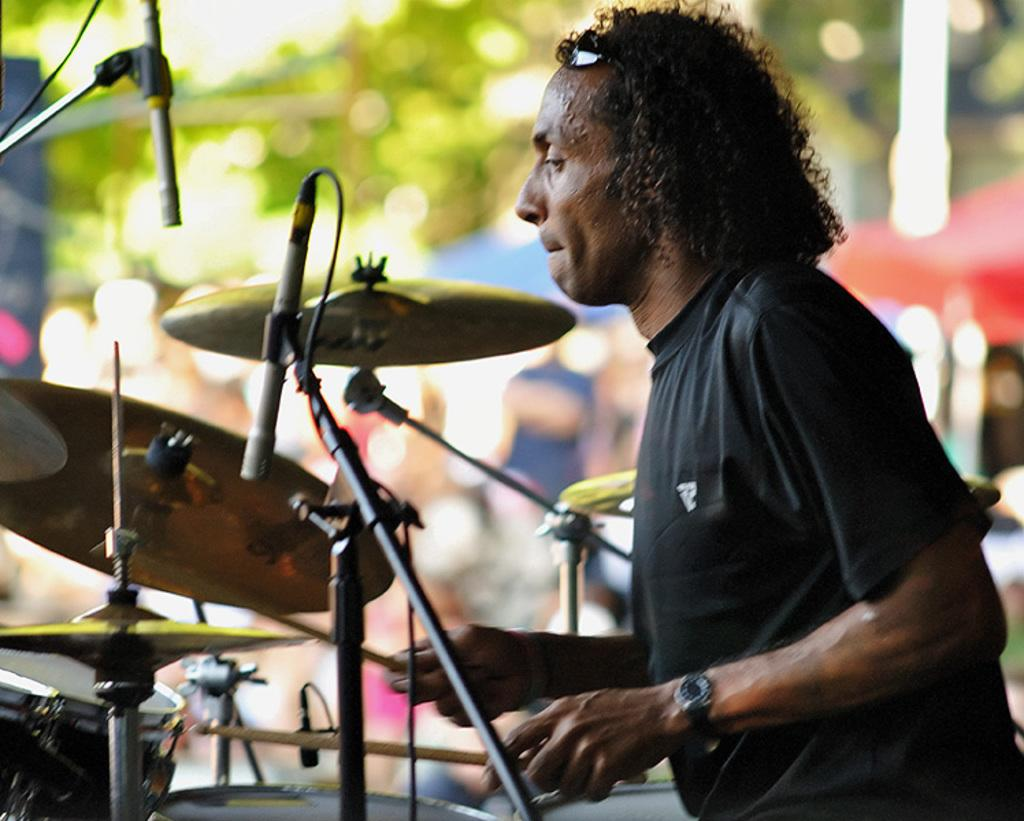What is the main subject of the image? The main subject of the image is a man. What is the man doing in the image? The man is playing a musical instrument in the image. What is the man holding in his hand? The man is holding two sticks in his hand. Can you hear the bells ringing of bells in the image? There is no mention of bells in the image, and therefore no sound can be heard. What type of parent is the man in the image? The image does not provide any information about the man's parental status, so it cannot be determined. 